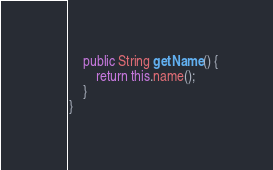<code> <loc_0><loc_0><loc_500><loc_500><_Java_>	public String getName() {
		return this.name();
	}
}
</code> 